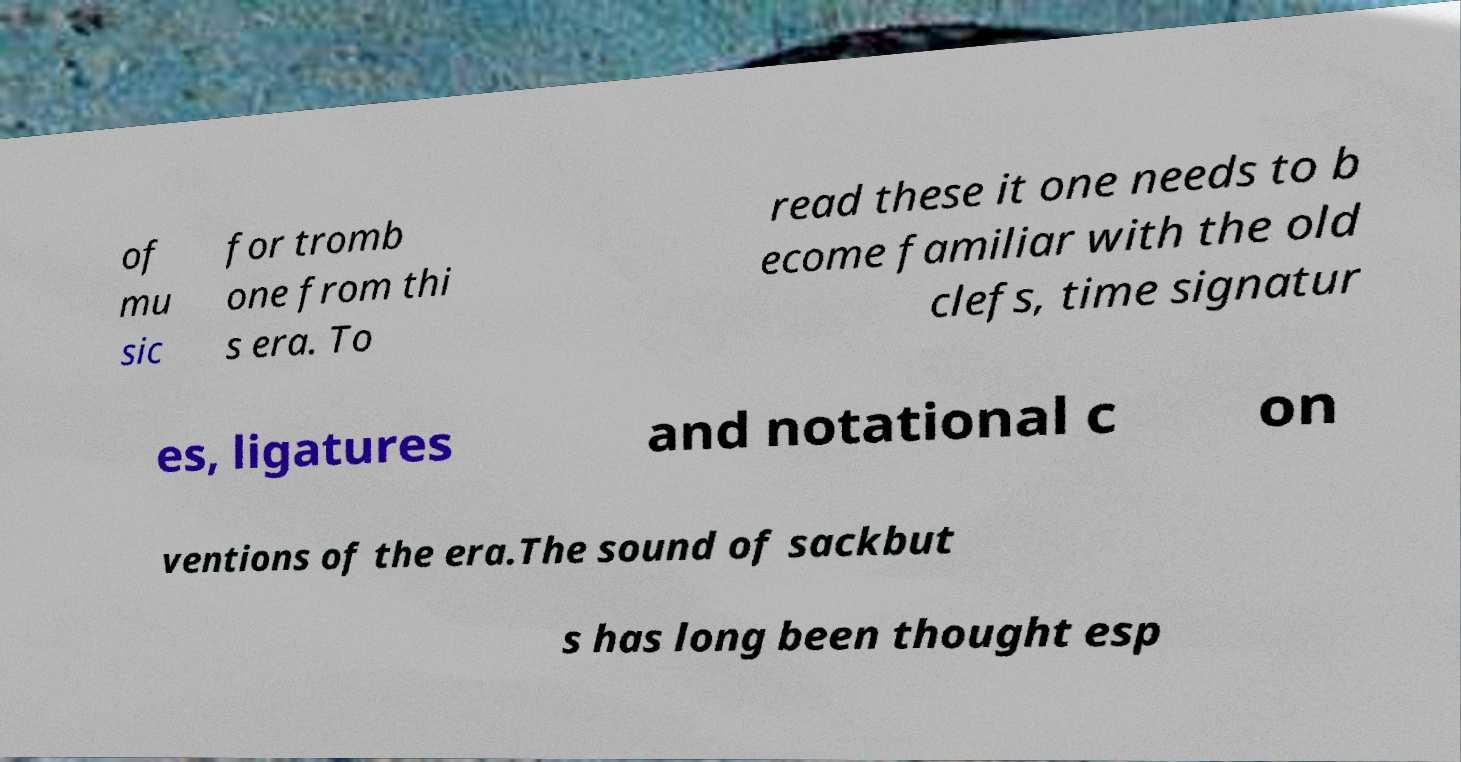Could you assist in decoding the text presented in this image and type it out clearly? of mu sic for tromb one from thi s era. To read these it one needs to b ecome familiar with the old clefs, time signatur es, ligatures and notational c on ventions of the era.The sound of sackbut s has long been thought esp 